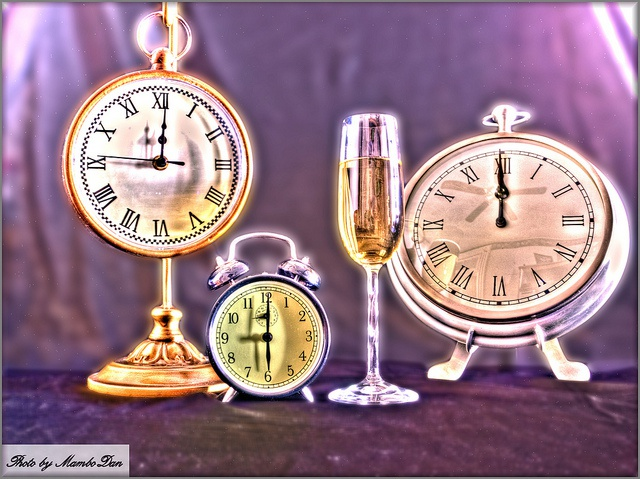Describe the objects in this image and their specific colors. I can see clock in gray, white, lightpink, tan, and black tones, clock in gray, white, khaki, orange, and lightpink tones, wine glass in gray, white, tan, brown, and pink tones, and clock in gray, khaki, ivory, and tan tones in this image. 